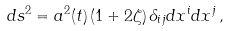Convert formula to latex. <formula><loc_0><loc_0><loc_500><loc_500>d s ^ { 2 } = a ^ { 2 } ( t ) \left ( 1 + 2 \zeta \right ) \delta _ { i j } d x ^ { i } d x ^ { j } \, ,</formula> 